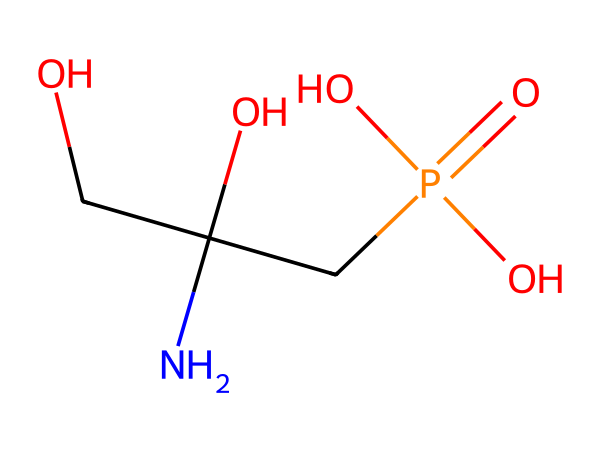What is the molecular formula of glyphosate? The SMILES representation can be used to determine the molecular formula by counting the atoms of each element present. The structure indicates there are two carbon (C) atoms, one nitrogen (N) atom, one phosphorus (P) atom, four oxygen (O) atoms, and four hydrogen (H) atoms. Combining these gives us the molecular formula C3H9N2O4P.
Answer: C3H9N2O4P How many oxygen atoms are in glyphosate? From the SMILES representation, we can see that there are four oxygen (O) atoms present in the structure. They are located in various functional groups within the molecule.
Answer: four What functional groups are present in glyphosate? By analyzing the structure, we see the presence of a hydroxyl group (-OH), amine group (-NH), and a phosphonate group (which contains the phosphorus atom bonded to oxygen). These functional groups are critical to glyphosate's activity as an herbicide.
Answer: hydroxyl, amine, phosphonate What physical state is glyphosate typically found in? Glyphosate is commonly found in a soluble salt form when used in agricultural applications, which indicates that it is often present in a liquid or wet form due to its solubility in water.
Answer: liquid Is glyphosate a broad-spectrum herbicide? Glyphosate acts as a systemic herbicide that targets a wide range of plants, making it effective against many types of weeds. This characteristic defines its classification as a broad-spectrum herbicide.
Answer: yes What element in glyphosate is responsible for its herbicidal properties? The unique structure of glyphosate contains a nitrogen atom, which plays a vital role in inhibiting a specific enzyme pathway in plants, contributing to its effectiveness as a herbicide.
Answer: nitrogen How many carbon atoms are present in glyphosate? The structure shows that there are three carbon (C) atoms in the glyphosate molecule based on the connections depicted in the SMILES representation.
Answer: three 